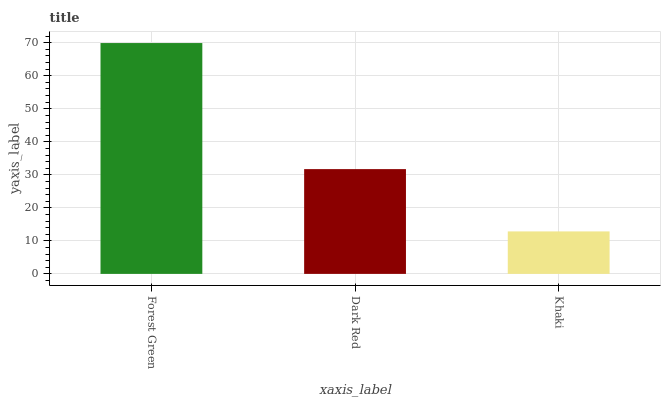Is Dark Red the minimum?
Answer yes or no. No. Is Dark Red the maximum?
Answer yes or no. No. Is Forest Green greater than Dark Red?
Answer yes or no. Yes. Is Dark Red less than Forest Green?
Answer yes or no. Yes. Is Dark Red greater than Forest Green?
Answer yes or no. No. Is Forest Green less than Dark Red?
Answer yes or no. No. Is Dark Red the high median?
Answer yes or no. Yes. Is Dark Red the low median?
Answer yes or no. Yes. Is Forest Green the high median?
Answer yes or no. No. Is Khaki the low median?
Answer yes or no. No. 